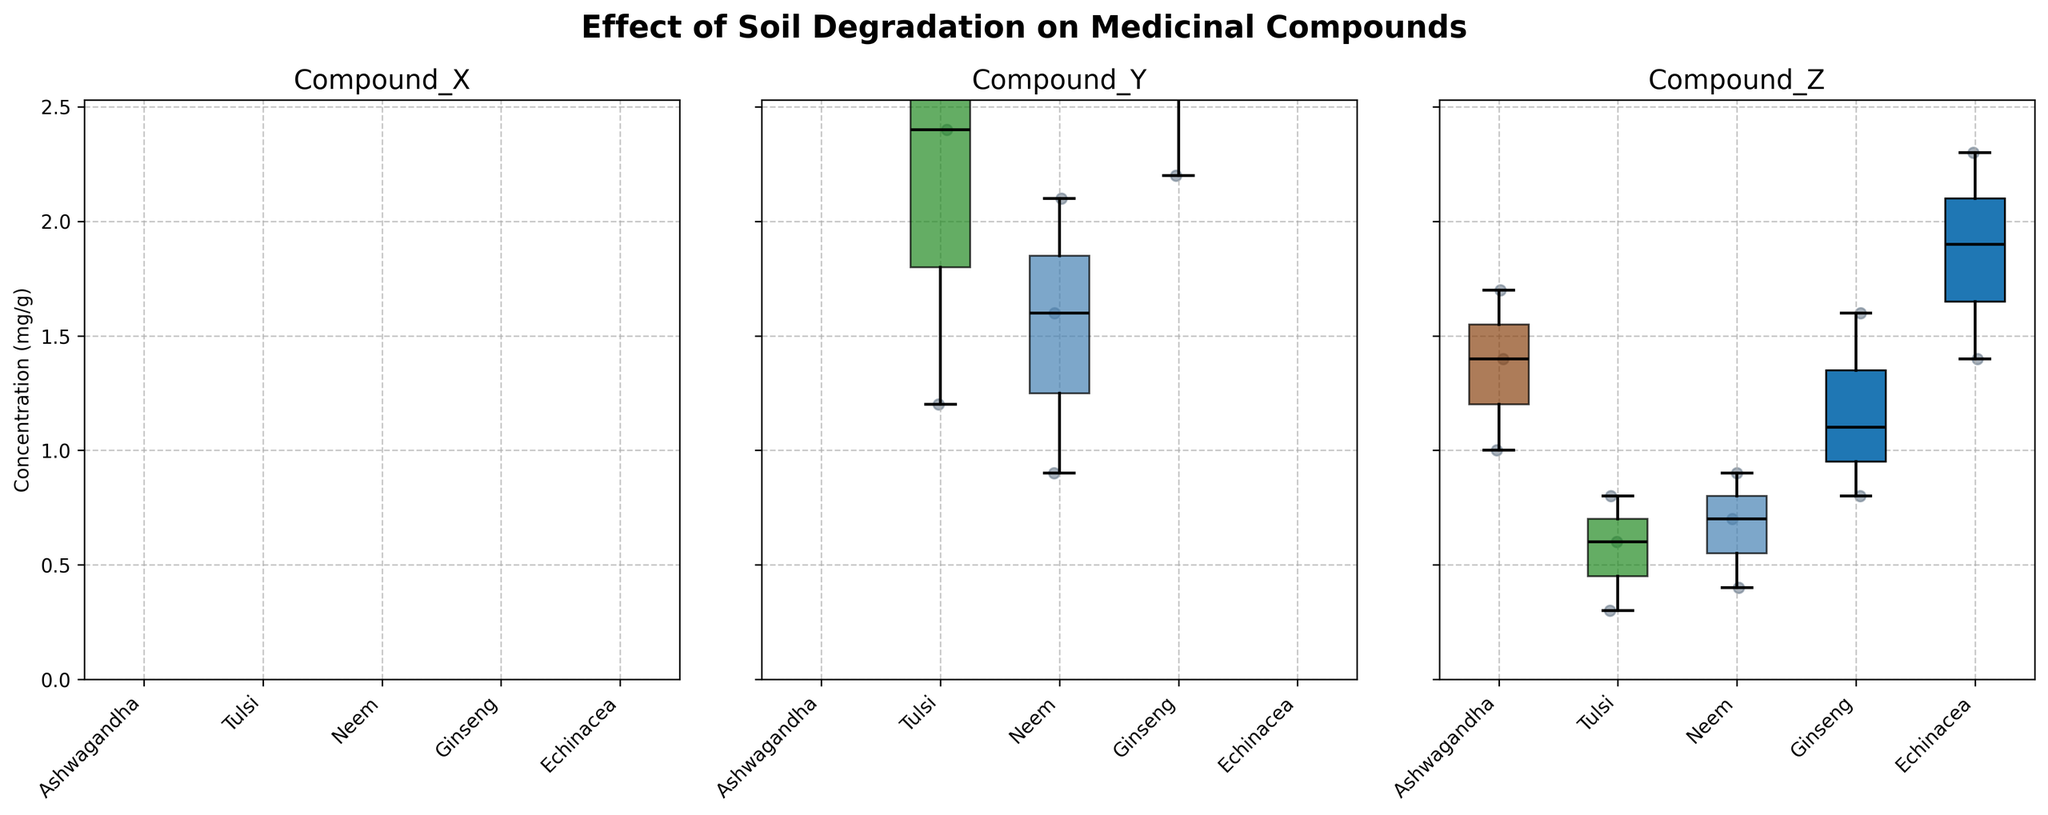Which plant has the highest median concentration of Compound_X? Observing the box plots for Compound_X, Echinacea has the highest median concentration as indicated by the central line within the box being positioned the highest on the plot.
Answer: Echinacea How does soil degradation affect the concentration of Compound_Y in Tulsi? From the box plots for Compound_Y, the concentration decreases from Low to Moderate to High soil degradation levels in Tulsi.
Answer: Decreases What is the range of Compound_Z concentration in Ashwagandha? For Ashwagandha, the lowest concentration of Compound_Z appears around 1.0 mg/g and the highest around 1.7 mg/g. Hence, the range is 1.7 - 1.0.
Answer: 0.7 mg/g Which plant shows the least variation in Compound_Y concentrations across different soil degradation levels? By comparing the widths of the boxes (interquartile ranges) for Compound_Y, Neem has the least variation as its box is relatively narrower compared to others.
Answer: Neem How does the median concentration of Compound_X in Ginseng compare to that in Neem? For Compound_X, Ginseng's median concentration is higher than Neem's, as seen by the position of the median line within each box plot.
Answer: Higher Which compound shows the greatest overall decrease in concentration with increasing soil degradation for all plants? By examining all the box plots, Compound_X exhibits the greatest decrease in median concentrations as the soil degradation level increases for all plants.
Answer: Compound_X What is the median concentration of Compound_Z in Echinacea? Observing the box plot for Compound_Z for Echinacea, the median line is around 1.9 mg/g.
Answer: 1.9 mg/g Which plant's concentration of Compound_X shows the greatest drop from Low to High soil degradation? Ashwagandha's concentration of Compound_X drops from around 18.4 mg/g (Low) to 11.3 mg/g (High), which is a more significant drop compared to other plants.
Answer: Ashwagandha Are there any plants where Compound_Y's concentration remains relatively stable across soil degradation levels? By looking at the Compound_Y box plots, none of the plants show a stable concentration across varying soil degradation levels; all show a noticeable decrease.
Answer: No How does the median concentration of Compound_Z in Western Ghats compare with the median concentration of Compound_Z in the Amazon Forest? For Western Ghats (Tulsi), the median concentration is lower than in the Amazon Forest (Ashwagandha) at each corresponding soil degradation level.
Answer: Lower 